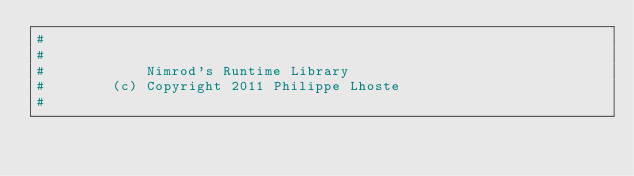<code> <loc_0><loc_0><loc_500><loc_500><_Nim_>#
#
#            Nimrod's Runtime Library
#        (c) Copyright 2011 Philippe Lhoste
#</code> 